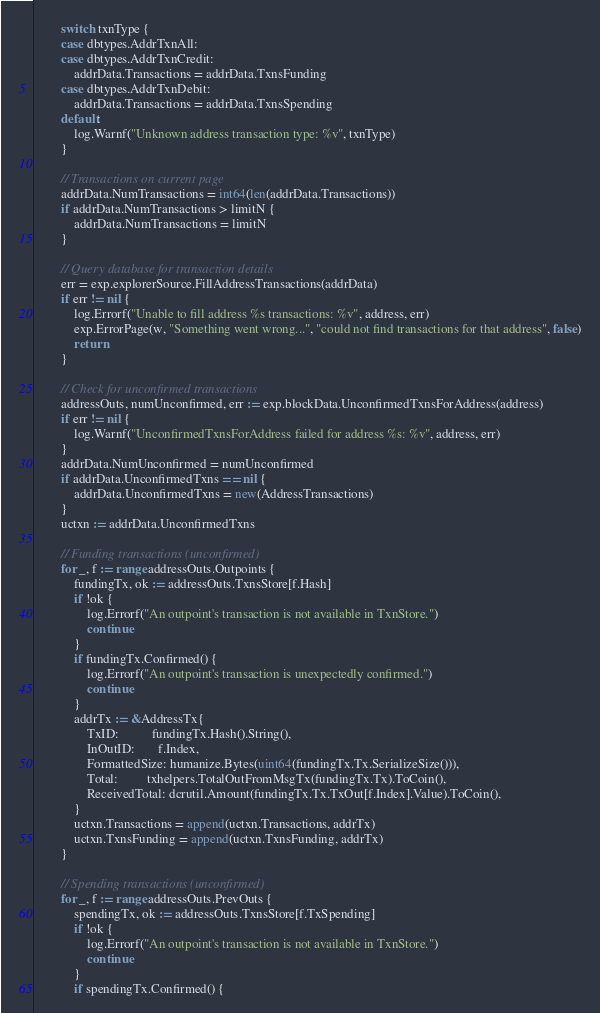Convert code to text. <code><loc_0><loc_0><loc_500><loc_500><_Go_>		switch txnType {
		case dbtypes.AddrTxnAll:
		case dbtypes.AddrTxnCredit:
			addrData.Transactions = addrData.TxnsFunding
		case dbtypes.AddrTxnDebit:
			addrData.Transactions = addrData.TxnsSpending
		default:
			log.Warnf("Unknown address transaction type: %v", txnType)
		}

		// Transactions on current page
		addrData.NumTransactions = int64(len(addrData.Transactions))
		if addrData.NumTransactions > limitN {
			addrData.NumTransactions = limitN
		}

		// Query database for transaction details
		err = exp.explorerSource.FillAddressTransactions(addrData)
		if err != nil {
			log.Errorf("Unable to fill address %s transactions: %v", address, err)
			exp.ErrorPage(w, "Something went wrong...", "could not find transactions for that address", false)
			return
		}

		// Check for unconfirmed transactions
		addressOuts, numUnconfirmed, err := exp.blockData.UnconfirmedTxnsForAddress(address)
		if err != nil {
			log.Warnf("UnconfirmedTxnsForAddress failed for address %s: %v", address, err)
		}
		addrData.NumUnconfirmed = numUnconfirmed
		if addrData.UnconfirmedTxns == nil {
			addrData.UnconfirmedTxns = new(AddressTransactions)
		}
		uctxn := addrData.UnconfirmedTxns

		// Funding transactions (unconfirmed)
		for _, f := range addressOuts.Outpoints {
			fundingTx, ok := addressOuts.TxnsStore[f.Hash]
			if !ok {
				log.Errorf("An outpoint's transaction is not available in TxnStore.")
				continue
			}
			if fundingTx.Confirmed() {
				log.Errorf("An outpoint's transaction is unexpectedly confirmed.")
				continue
			}
			addrTx := &AddressTx{
				TxID:          fundingTx.Hash().String(),
				InOutID:       f.Index,
				FormattedSize: humanize.Bytes(uint64(fundingTx.Tx.SerializeSize())),
				Total:         txhelpers.TotalOutFromMsgTx(fundingTx.Tx).ToCoin(),
				ReceivedTotal: dcrutil.Amount(fundingTx.Tx.TxOut[f.Index].Value).ToCoin(),
			}
			uctxn.Transactions = append(uctxn.Transactions, addrTx)
			uctxn.TxnsFunding = append(uctxn.TxnsFunding, addrTx)
		}

		// Spending transactions (unconfirmed)
		for _, f := range addressOuts.PrevOuts {
			spendingTx, ok := addressOuts.TxnsStore[f.TxSpending]
			if !ok {
				log.Errorf("An outpoint's transaction is not available in TxnStore.")
				continue
			}
			if spendingTx.Confirmed() {</code> 